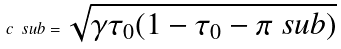<formula> <loc_0><loc_0><loc_500><loc_500>c \ s u b = \sqrt { \gamma \tau _ { 0 } ( 1 - \tau _ { 0 } - \pi \ s u b ) }</formula> 